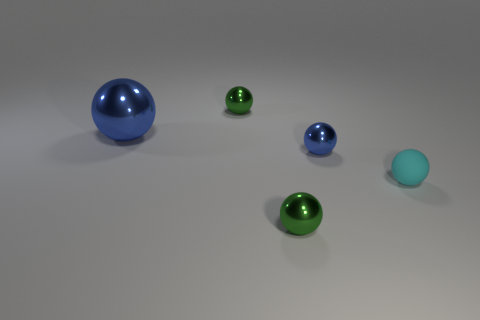There is a large blue metallic sphere; what number of tiny matte things are on the right side of it?
Your response must be concise. 1. Do the small rubber object that is right of the big blue ball and the large metallic thing have the same color?
Ensure brevity in your answer.  No. What number of cyan objects are tiny metal spheres or small things?
Offer a very short reply. 1. The object that is on the left side of the green shiny ball behind the tiny cyan rubber sphere is what color?
Make the answer very short. Blue. There is a thing that is the same color as the large sphere; what is its material?
Provide a succinct answer. Metal. What color is the big thing behind the tiny blue thing?
Provide a succinct answer. Blue. Is the size of the metal ball that is in front of the rubber ball the same as the cyan thing?
Your answer should be very brief. Yes. There is another sphere that is the same color as the big shiny sphere; what size is it?
Your response must be concise. Small. Are there any cyan shiny balls of the same size as the cyan matte thing?
Offer a very short reply. No. Do the metallic sphere in front of the tiny cyan rubber thing and the big shiny thing that is behind the small cyan thing have the same color?
Make the answer very short. No. 